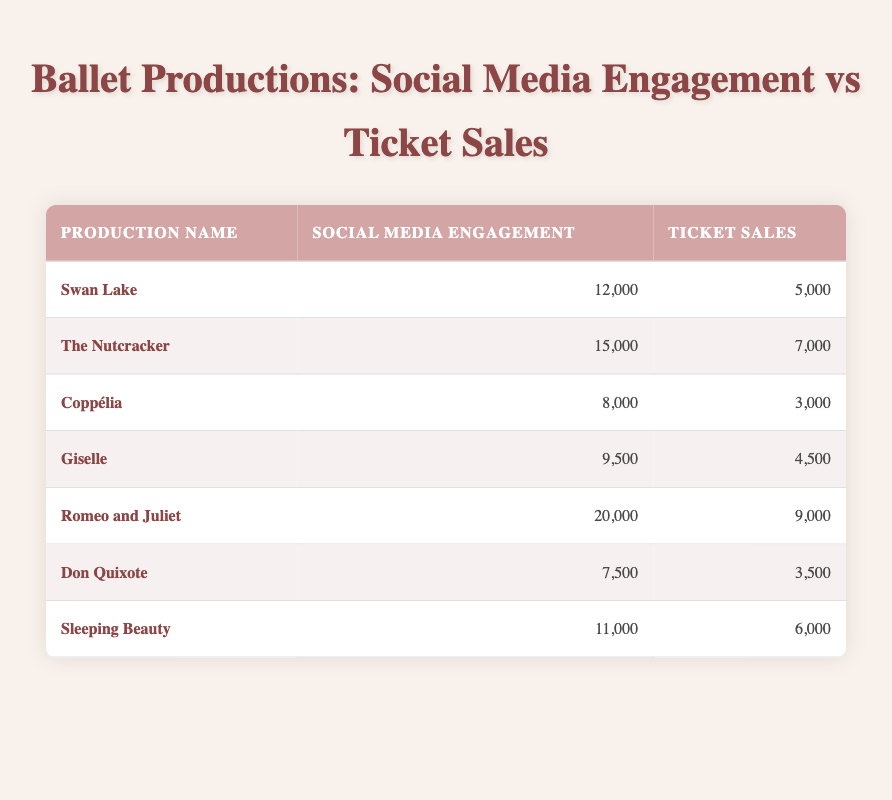What is the highest social media engagement recorded? By looking at the "Social Media Engagement" column, the highest value is 20,000, associated with the production "Romeo and Juliet".
Answer: 20,000 Which ballet production had the lowest ticket sales? The "Ticket Sales" column shows that the lowest value is 3,000, which corresponds to the production "Coppélia" and "Don Quixote".
Answer: 3,000 What is the total social media engagement for all productions? Adding the values of the "Social Media Engagement" column: 12000 + 15000 + 8000 + 9500 + 20000 + 7500 + 11000 = 82000.
Answer: 82,000 Is the relationship between social media engagement and ticket sales positive? A positive correlation means that as social media engagement increases, ticket sales also increase. Observing the data, higher engagement often corresponds with higher ticket sales. For example, "Romeo and Juliet" has the highest engagement and ticket sales.
Answer: Yes Which production had more ticket sales than social media engagement? Comparing each production's ticket sales to its social media engagement, "Coppélia" (3,000 vs 8,000) and "Don Quixote" (3,500 vs 7,500) are the only productions where ticket sales are less than social media engagement.
Answer: None 